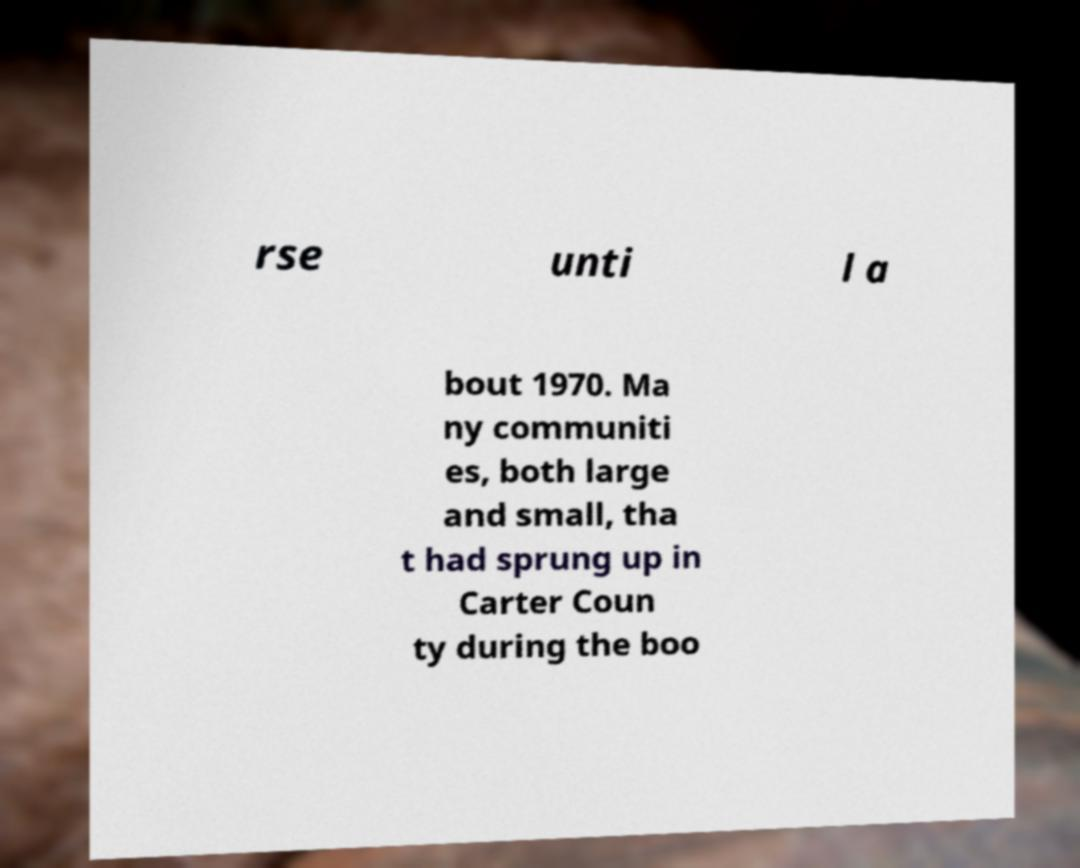Can you read and provide the text displayed in the image?This photo seems to have some interesting text. Can you extract and type it out for me? rse unti l a bout 1970. Ma ny communiti es, both large and small, tha t had sprung up in Carter Coun ty during the boo 